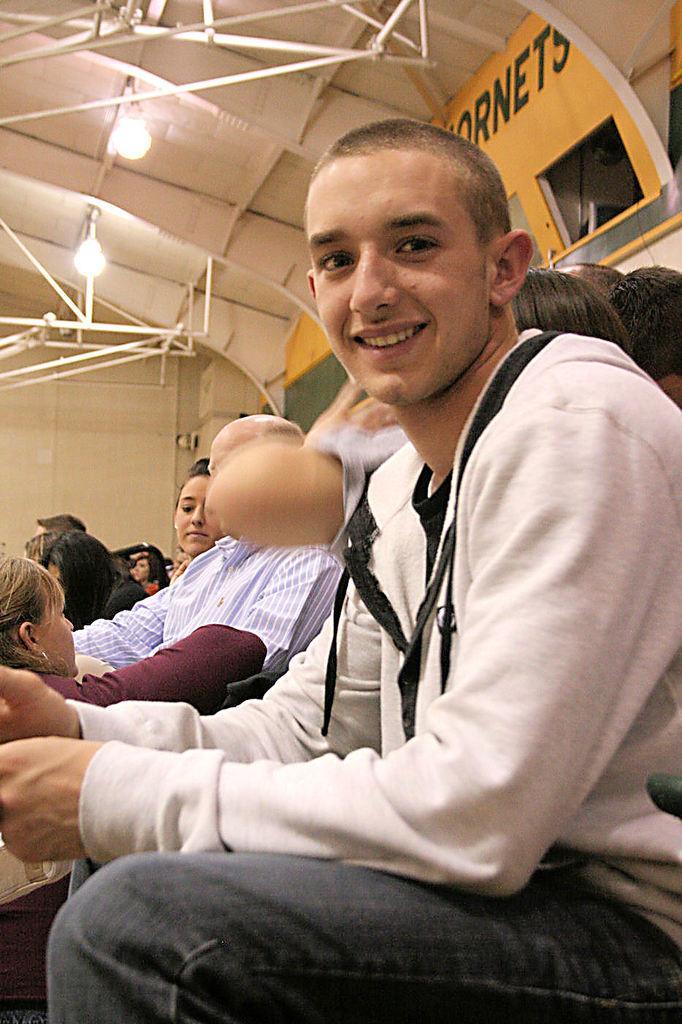Can you describe this image briefly? This picture describes about group of people, they are seated, in the left side of the given image we can see a man he is smiling, and also we can see few lights and metal rods. 